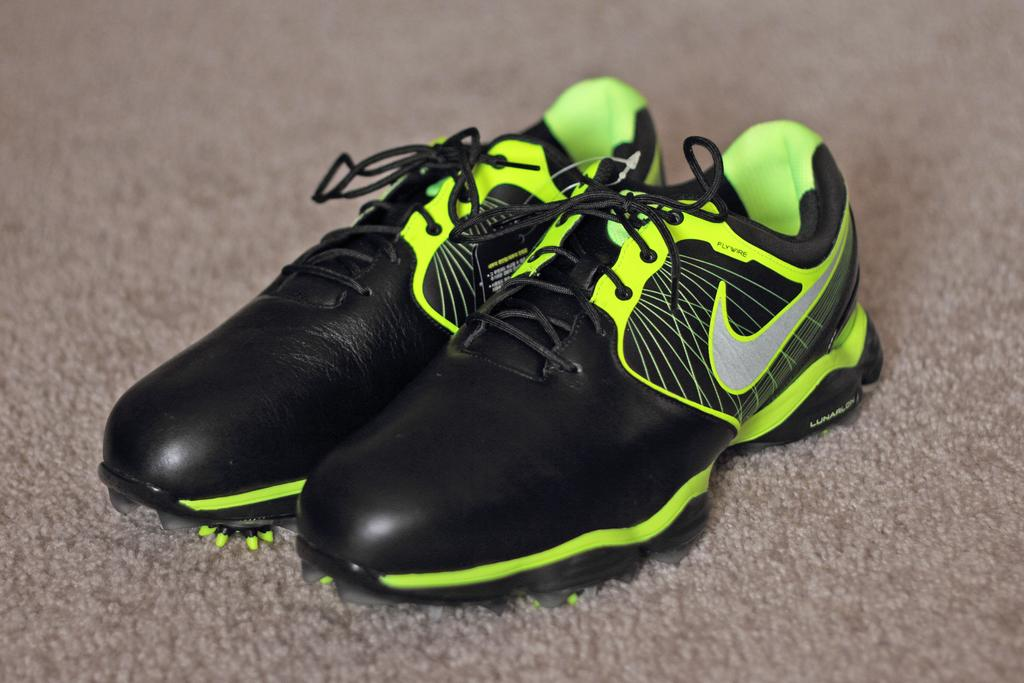What objects are in the image? There are shoes in the image. Where are the shoes located? The shoes are on a carpet. What type of juice is being poured in the image? There is no juice present in the image; it only features shoes on a carpet. 